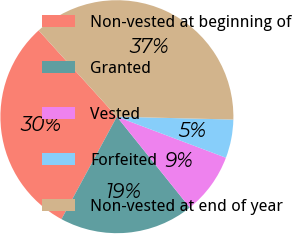Convert chart. <chart><loc_0><loc_0><loc_500><loc_500><pie_chart><fcel>Non-vested at beginning of<fcel>Granted<fcel>Vested<fcel>Forfeited<fcel>Non-vested at end of year<nl><fcel>30.38%<fcel>18.65%<fcel>8.51%<fcel>5.34%<fcel>37.12%<nl></chart> 